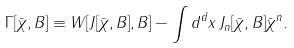Convert formula to latex. <formula><loc_0><loc_0><loc_500><loc_500>\Gamma [ \bar { \chi } , B ] \equiv W [ J [ \bar { \chi } , B ] , B ] - \int d ^ { d } x \, J _ { n } [ \bar { \chi } , B ] \bar { \chi } ^ { n } .</formula> 